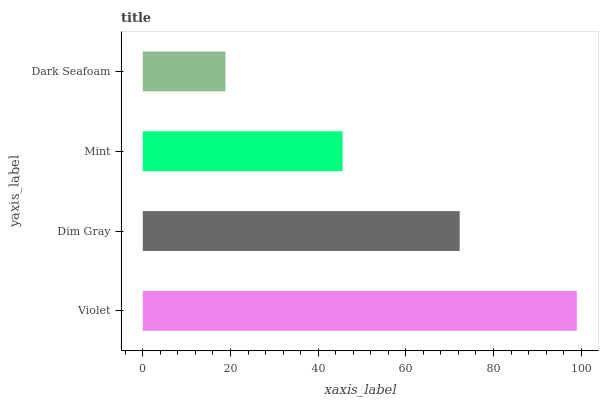Is Dark Seafoam the minimum?
Answer yes or no. Yes. Is Violet the maximum?
Answer yes or no. Yes. Is Dim Gray the minimum?
Answer yes or no. No. Is Dim Gray the maximum?
Answer yes or no. No. Is Violet greater than Dim Gray?
Answer yes or no. Yes. Is Dim Gray less than Violet?
Answer yes or no. Yes. Is Dim Gray greater than Violet?
Answer yes or no. No. Is Violet less than Dim Gray?
Answer yes or no. No. Is Dim Gray the high median?
Answer yes or no. Yes. Is Mint the low median?
Answer yes or no. Yes. Is Violet the high median?
Answer yes or no. No. Is Violet the low median?
Answer yes or no. No. 